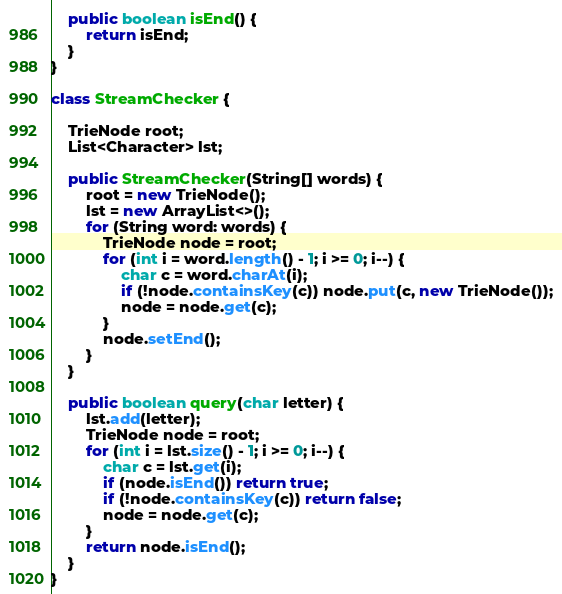Convert code to text. <code><loc_0><loc_0><loc_500><loc_500><_Java_>
    public boolean isEnd() {
        return isEnd;
    }
}

class StreamChecker {
    
    TrieNode root;
    List<Character> lst;

    public StreamChecker(String[] words) {
        root = new TrieNode();
        lst = new ArrayList<>();
        for (String word: words) {
            TrieNode node = root;
            for (int i = word.length() - 1; i >= 0; i--) {
                char c = word.charAt(i);
                if (!node.containsKey(c)) node.put(c, new TrieNode());
                node = node.get(c);
            }
            node.setEnd();
        }
    }
    
    public boolean query(char letter) {
        lst.add(letter);
        TrieNode node = root;
        for (int i = lst.size() - 1; i >= 0; i--) {
            char c = lst.get(i);
            if (node.isEnd()) return true;
            if (!node.containsKey(c)) return false;
            node = node.get(c);
        }
        return node.isEnd();
    }
}
</code> 